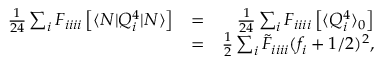<formula> <loc_0><loc_0><loc_500><loc_500>\begin{array} { r l r } { \frac { 1 } { 2 4 } \sum _ { i } F _ { i i i i } \left [ \langle N | Q _ { i } ^ { 4 } | N \rangle \right ] } & { = } & { \frac { 1 } { 2 4 } \sum _ { i } F _ { i i i i } \left [ \langle { Q _ { i } ^ { 4 } } \rangle _ { 0 } \right ] } \\ & { = } & { \frac { 1 } { 2 } \sum _ { i } \tilde { F } _ { i i i i } { ( f _ { i } + 1 / 2 ) ^ { 2 } } , } \end{array}</formula> 